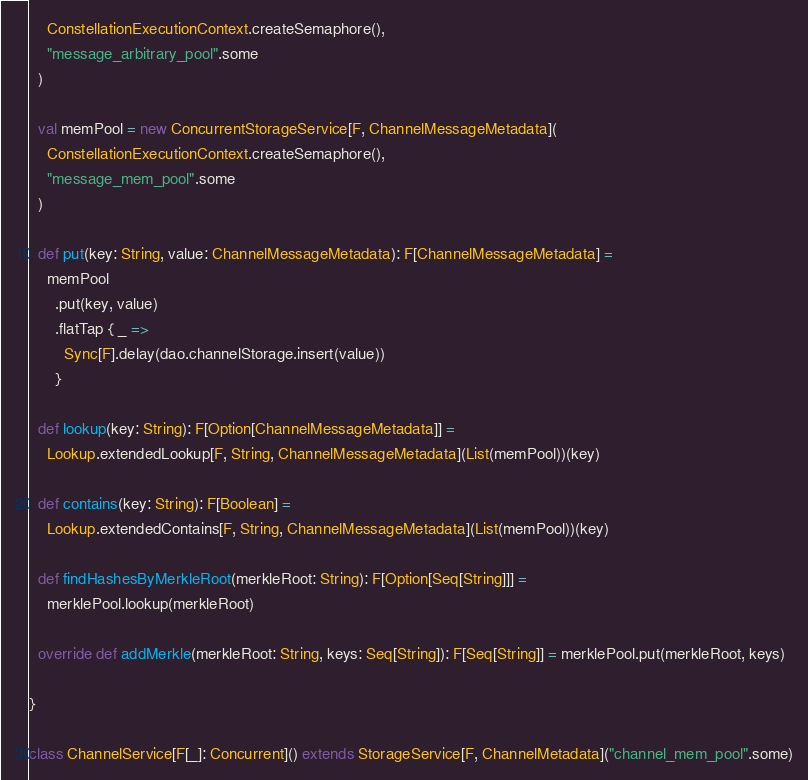<code> <loc_0><loc_0><loc_500><loc_500><_Scala_>    ConstellationExecutionContext.createSemaphore(),
    "message_arbitrary_pool".some
  )

  val memPool = new ConcurrentStorageService[F, ChannelMessageMetadata](
    ConstellationExecutionContext.createSemaphore(),
    "message_mem_pool".some
  )

  def put(key: String, value: ChannelMessageMetadata): F[ChannelMessageMetadata] =
    memPool
      .put(key, value)
      .flatTap { _ =>
        Sync[F].delay(dao.channelStorage.insert(value))
      }

  def lookup(key: String): F[Option[ChannelMessageMetadata]] =
    Lookup.extendedLookup[F, String, ChannelMessageMetadata](List(memPool))(key)

  def contains(key: String): F[Boolean] =
    Lookup.extendedContains[F, String, ChannelMessageMetadata](List(memPool))(key)

  def findHashesByMerkleRoot(merkleRoot: String): F[Option[Seq[String]]] =
    merklePool.lookup(merkleRoot)

  override def addMerkle(merkleRoot: String, keys: Seq[String]): F[Seq[String]] = merklePool.put(merkleRoot, keys)

}

class ChannelService[F[_]: Concurrent]() extends StorageService[F, ChannelMetadata]("channel_mem_pool".some)
</code> 